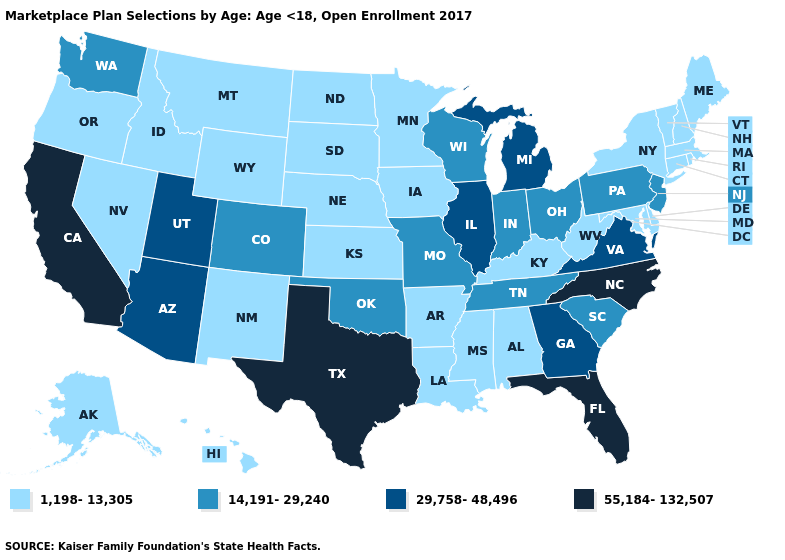Does Oregon have the lowest value in the USA?
Write a very short answer. Yes. What is the value of Virginia?
Keep it brief. 29,758-48,496. Name the states that have a value in the range 1,198-13,305?
Quick response, please. Alabama, Alaska, Arkansas, Connecticut, Delaware, Hawaii, Idaho, Iowa, Kansas, Kentucky, Louisiana, Maine, Maryland, Massachusetts, Minnesota, Mississippi, Montana, Nebraska, Nevada, New Hampshire, New Mexico, New York, North Dakota, Oregon, Rhode Island, South Dakota, Vermont, West Virginia, Wyoming. What is the highest value in the Northeast ?
Keep it brief. 14,191-29,240. Name the states that have a value in the range 29,758-48,496?
Answer briefly. Arizona, Georgia, Illinois, Michigan, Utah, Virginia. Does Arkansas have the same value as South Carolina?
Answer briefly. No. Does South Carolina have the lowest value in the USA?
Be succinct. No. What is the value of New Mexico?
Answer briefly. 1,198-13,305. Name the states that have a value in the range 1,198-13,305?
Short answer required. Alabama, Alaska, Arkansas, Connecticut, Delaware, Hawaii, Idaho, Iowa, Kansas, Kentucky, Louisiana, Maine, Maryland, Massachusetts, Minnesota, Mississippi, Montana, Nebraska, Nevada, New Hampshire, New Mexico, New York, North Dakota, Oregon, Rhode Island, South Dakota, Vermont, West Virginia, Wyoming. Which states have the highest value in the USA?
Keep it brief. California, Florida, North Carolina, Texas. Does the first symbol in the legend represent the smallest category?
Give a very brief answer. Yes. What is the lowest value in the USA?
Keep it brief. 1,198-13,305. Among the states that border New York , which have the lowest value?
Give a very brief answer. Connecticut, Massachusetts, Vermont. Among the states that border Illinois , which have the highest value?
Be succinct. Indiana, Missouri, Wisconsin. Name the states that have a value in the range 29,758-48,496?
Short answer required. Arizona, Georgia, Illinois, Michigan, Utah, Virginia. 